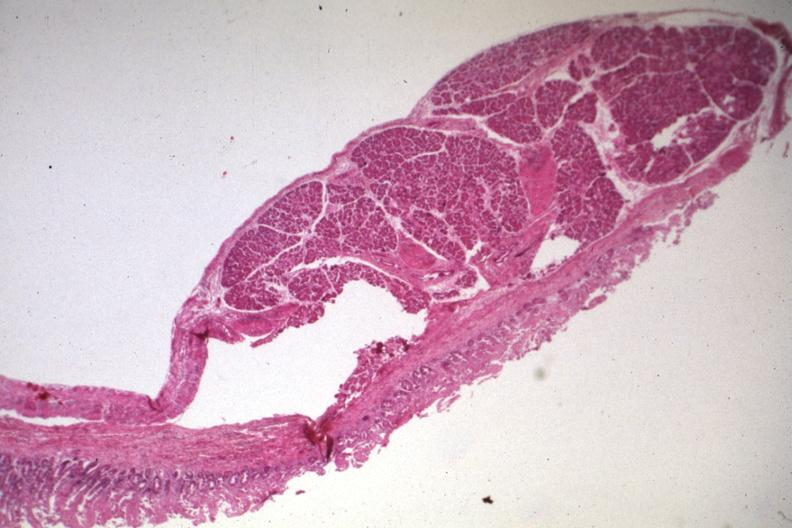what is present?
Answer the question using a single word or phrase. Gastrointestinal 